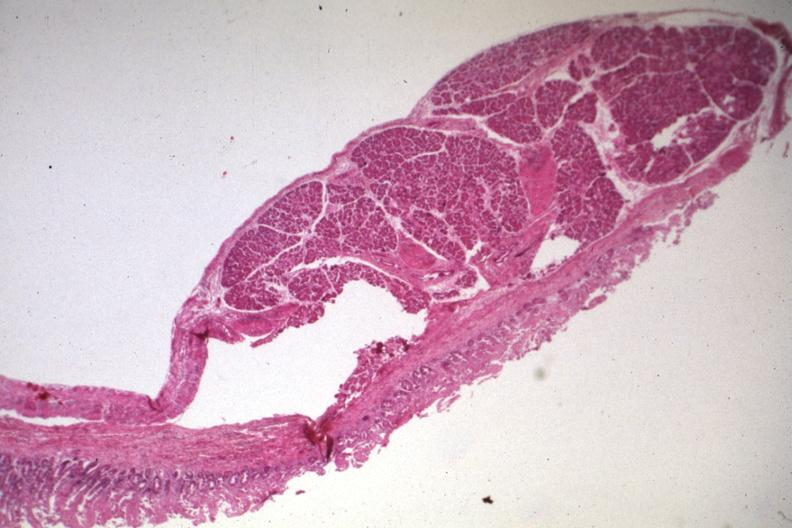what is present?
Answer the question using a single word or phrase. Gastrointestinal 